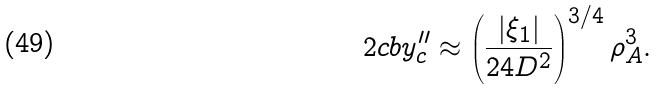Convert formula to latex. <formula><loc_0><loc_0><loc_500><loc_500>2 c b y _ { c } ^ { \prime \prime } \approx \left ( \frac { | \xi _ { 1 } | } { 2 4 D ^ { 2 } } \right ) ^ { 3 / 4 } \rho _ { A } ^ { 3 } .</formula> 